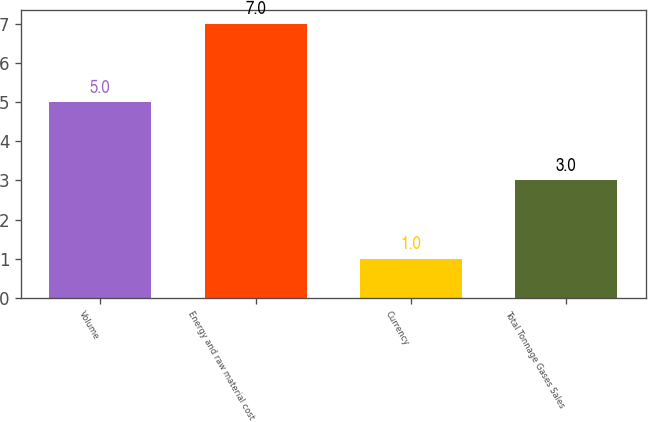Convert chart to OTSL. <chart><loc_0><loc_0><loc_500><loc_500><bar_chart><fcel>Volume<fcel>Energy and raw material cost<fcel>Currency<fcel>Total Tonnage Gases Sales<nl><fcel>5<fcel>7<fcel>1<fcel>3<nl></chart> 